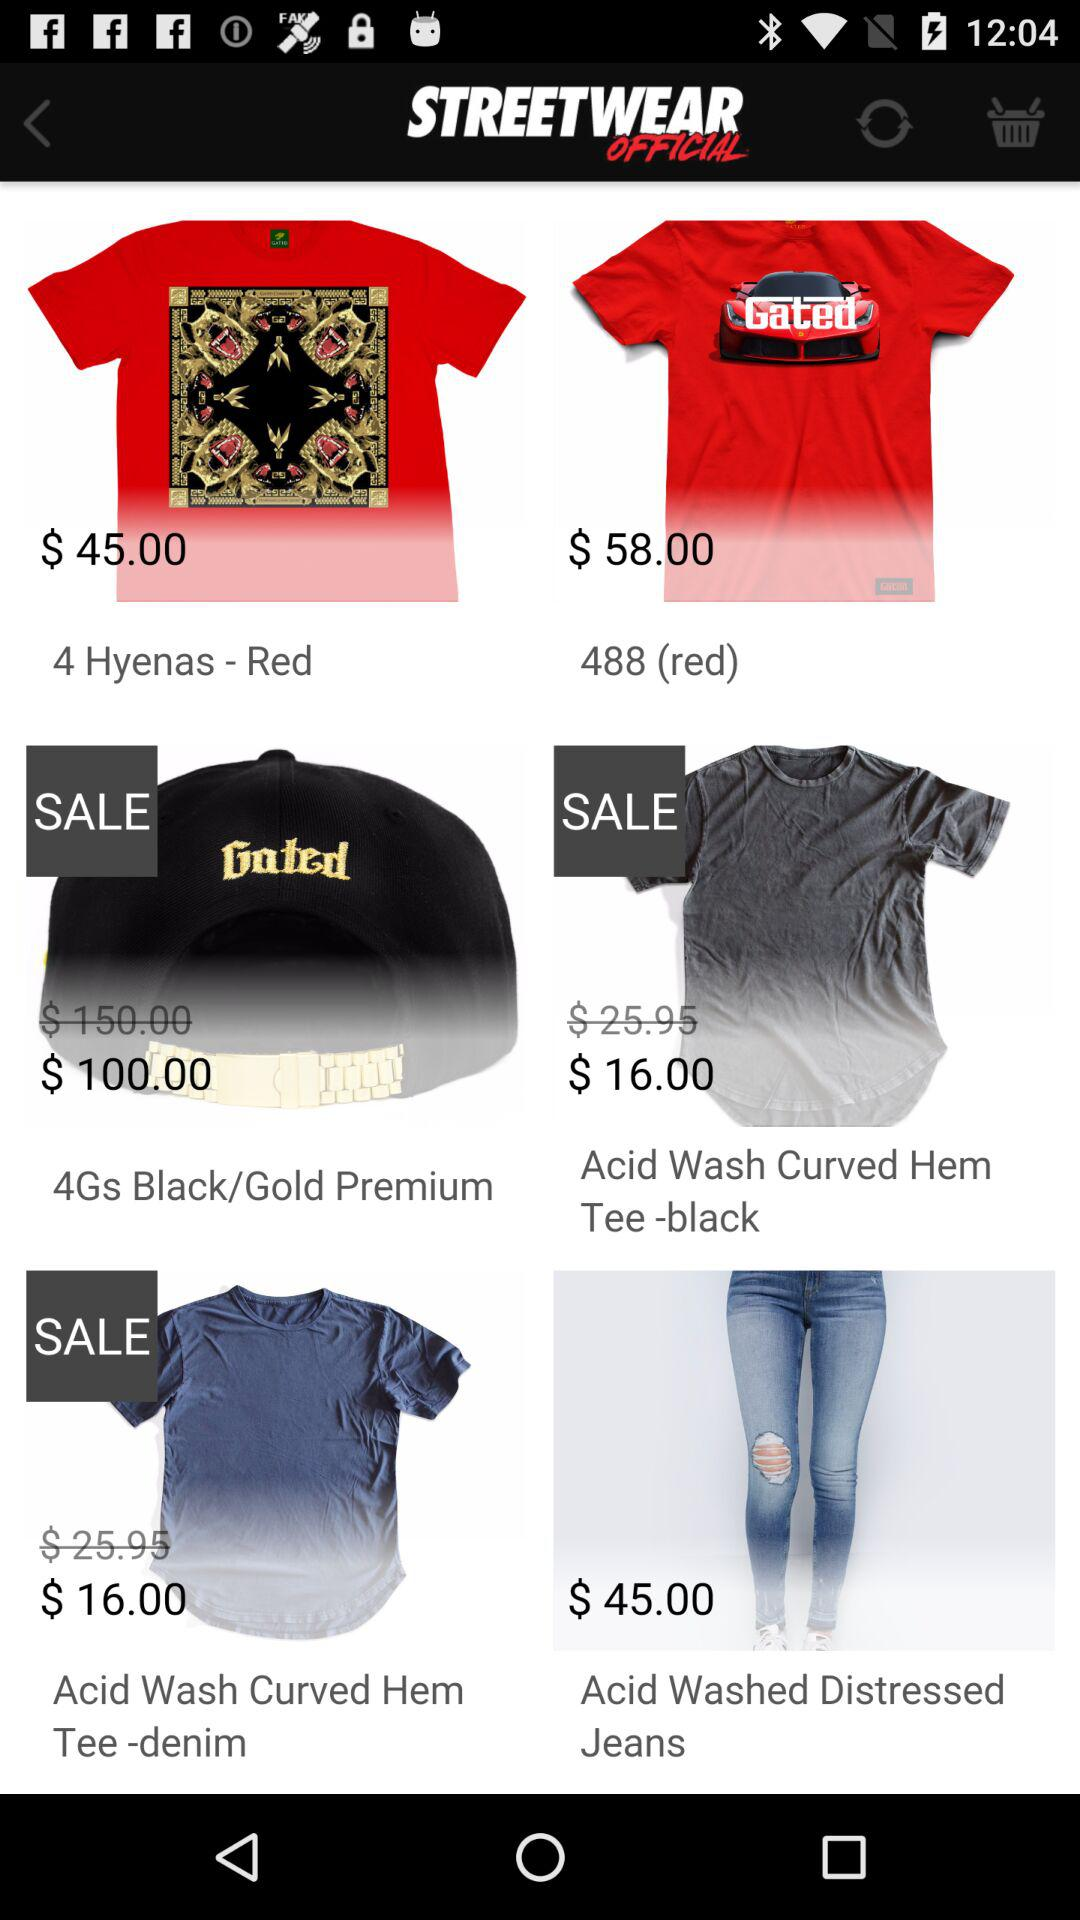What is the price of "4Gs Black/Gold Premium" after sale? The price of "4Gs Black/Gold Premium" is $100. 